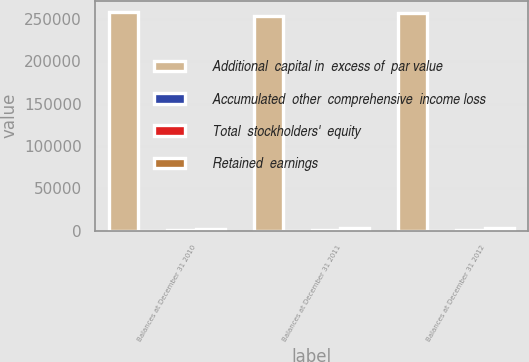Convert chart. <chart><loc_0><loc_0><loc_500><loc_500><stacked_bar_chart><ecel><fcel>Balances at December 31 2010<fcel>Balances at December 31 2011<fcel>Balances at December 31 2012<nl><fcel>Additional  capital in  excess of  par value<fcel>258760<fcel>253272<fcel>257018<nl><fcel>Accumulated  other  comprehensive  income loss<fcel>51.7<fcel>50.7<fcel>51.4<nl><fcel>Total  stockholders'  equity<fcel>506.3<fcel>502<fcel>631<nl><fcel>Retained  earnings<fcel>2599.4<fcel>2765.2<fcel>3031.8<nl></chart> 